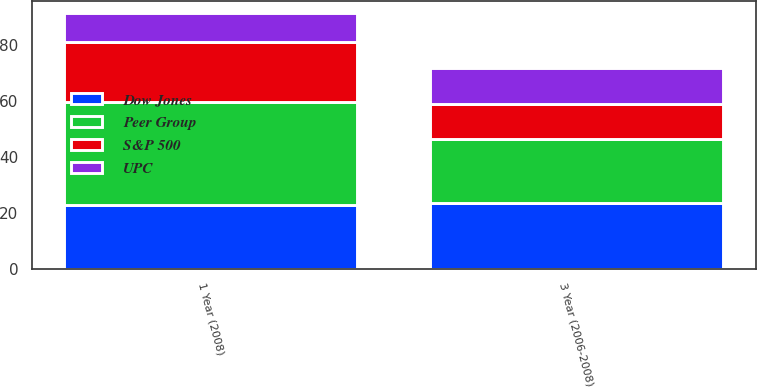<chart> <loc_0><loc_0><loc_500><loc_500><stacked_bar_chart><ecel><fcel>1 Year (2008)<fcel>3 Year (2006-2008)<nl><fcel>Dow Jones<fcel>22.7<fcel>23.4<nl><fcel>UPC<fcel>10.3<fcel>12.8<nl><fcel>S&P 500<fcel>21.4<fcel>12.6<nl><fcel>Peer Group<fcel>37<fcel>23<nl></chart> 